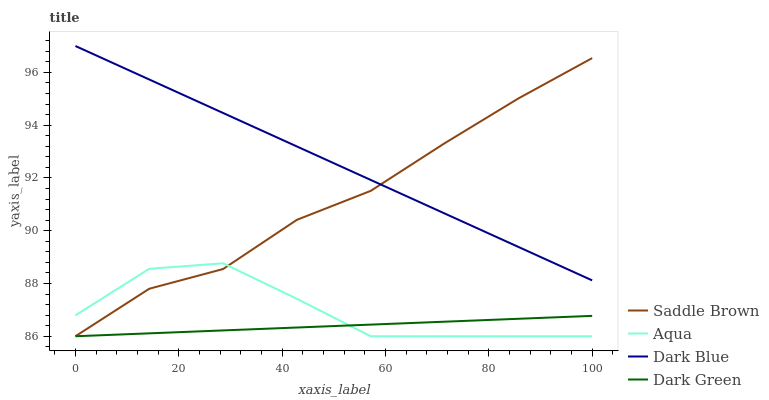Does Dark Green have the minimum area under the curve?
Answer yes or no. Yes. Does Dark Blue have the maximum area under the curve?
Answer yes or no. Yes. Does Aqua have the minimum area under the curve?
Answer yes or no. No. Does Aqua have the maximum area under the curve?
Answer yes or no. No. Is Dark Blue the smoothest?
Answer yes or no. Yes. Is Aqua the roughest?
Answer yes or no. Yes. Is Saddle Brown the smoothest?
Answer yes or no. No. Is Saddle Brown the roughest?
Answer yes or no. No. Does Aqua have the highest value?
Answer yes or no. No. Is Aqua less than Dark Blue?
Answer yes or no. Yes. Is Dark Blue greater than Dark Green?
Answer yes or no. Yes. Does Aqua intersect Dark Blue?
Answer yes or no. No. 